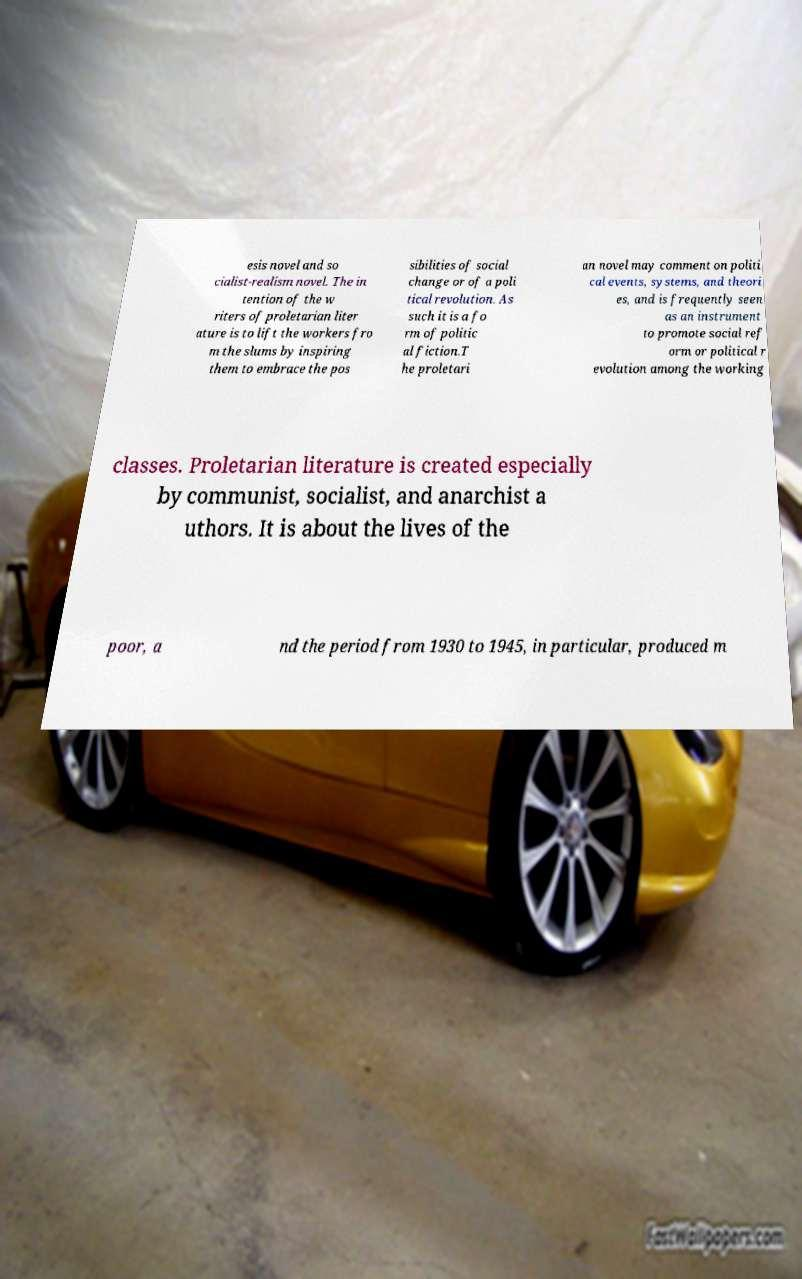I need the written content from this picture converted into text. Can you do that? esis novel and so cialist-realism novel. The in tention of the w riters of proletarian liter ature is to lift the workers fro m the slums by inspiring them to embrace the pos sibilities of social change or of a poli tical revolution. As such it is a fo rm of politic al fiction.T he proletari an novel may comment on politi cal events, systems, and theori es, and is frequently seen as an instrument to promote social ref orm or political r evolution among the working classes. Proletarian literature is created especially by communist, socialist, and anarchist a uthors. It is about the lives of the poor, a nd the period from 1930 to 1945, in particular, produced m 